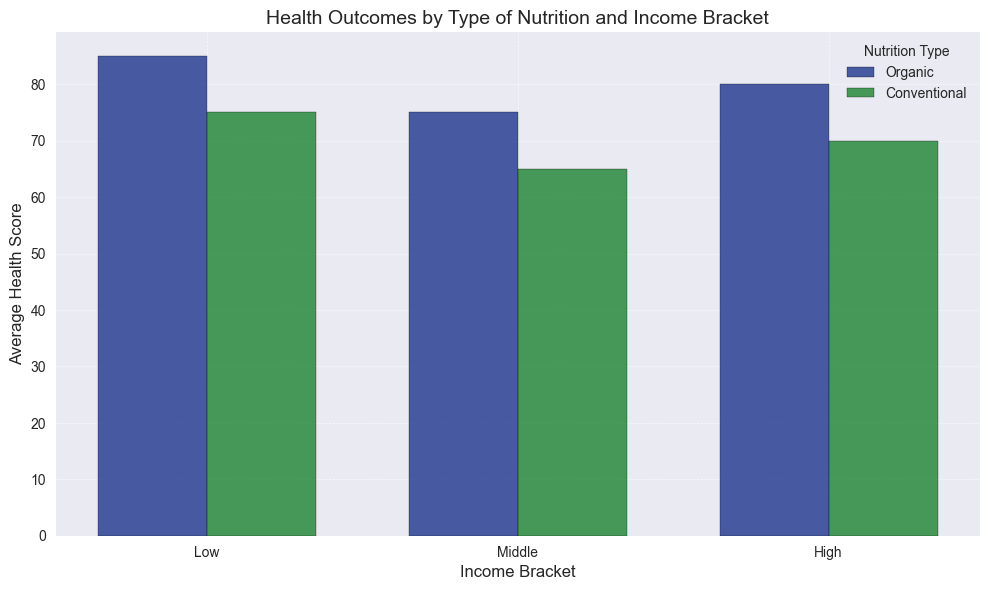What's the difference in average health score between low-income children receiving organic nutrition and those receiving conventional nutrition? The average health score for low-income children with organic nutrition is 75, and for those with conventional nutrition, it is 65. The difference is calculated as 75 - 65.
Answer: 10 Which income bracket shows the highest average health score for children receiving organic nutrition? By examining the height of the bars associated with organic nutrition across all income brackets, the high-income bracket has the tallest bar, indicating the highest average health score of 85.
Answer: High In the middle-income bracket, how much higher is the average health score for children receiving organic nutrition compared to conventional nutrition? The average health score for middle-income children with organic nutrition is 80, and for those with conventional nutrition, it is 70. The difference is calculated as 80 - 70.
Answer: 10 Which type of nutrition shows the greater variation in average health scores across all income brackets? To determine the variation, we can compare the difference in average health scores across income brackets for each nutrition type. For organic nutrition: 85 (High) - 75 (Low) = 10. For conventional nutrition: 75 (High) - 65 (Low) = 10. Both types show equal variation of 10.
Answer: Both show equal variation Does the average health score for conventional nutrition in the high-income bracket ever reach the average health score for organic nutrition in any income bracket? The highest average health score for conventional nutrition in the high-income bracket is 75, which reaches the average health score for organic nutrition in the low-income bracket.
Answer: Yes What is the combined average health score of organic nutrition for all income brackets? The average health scores for organic nutrition are 75 (Low), 80 (Middle), and 85 (High). The combined average is calculated as (75 + 80 + 85) / 3.
Answer: 80 What is the percentage increase in average health score from low to high-income bracket for conventional nutrition? The average health score for conventional nutrition increases from 65 (Low) to 75 (High). The percentage increase is calculated as ((75 - 65) / 65) * 100%.
Answer: 15.38% What is the range of average health scores for both organic and conventional nutrition types in the middle-income bracket? For the middle-income bracket, the average health score ranges from 70 (conventional) to 80 (organic). The range is calculated as 80 - 70.
Answer: 10 Which type of nutrition shows a consistent increase in average health score with increasing income? By visually assessing the bars for each income bracket, both organic and conventional nutrition show a consistent increase in average health score with increasing income, but organic consistently has higher values.
Answer: Both, but organic is higher Comparing organic nutrition across all income brackets, how does the height difference between bars indicate the change in health scores? The bars for organic nutrition increase in height from low (75) to middle (80) to high (85), indicating an increase in average health scores as income increases.
Answer: Increase with income 